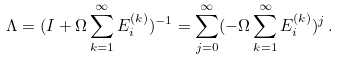<formula> <loc_0><loc_0><loc_500><loc_500>\Lambda = ( I + \Omega \sum _ { k = 1 } ^ { \infty } E _ { i } ^ { ( k ) } ) ^ { - 1 } = \sum _ { j = 0 } ^ { \infty } ( - \Omega \sum _ { k = 1 } ^ { \infty } E _ { i } ^ { ( k ) } ) ^ { j } \, .</formula> 